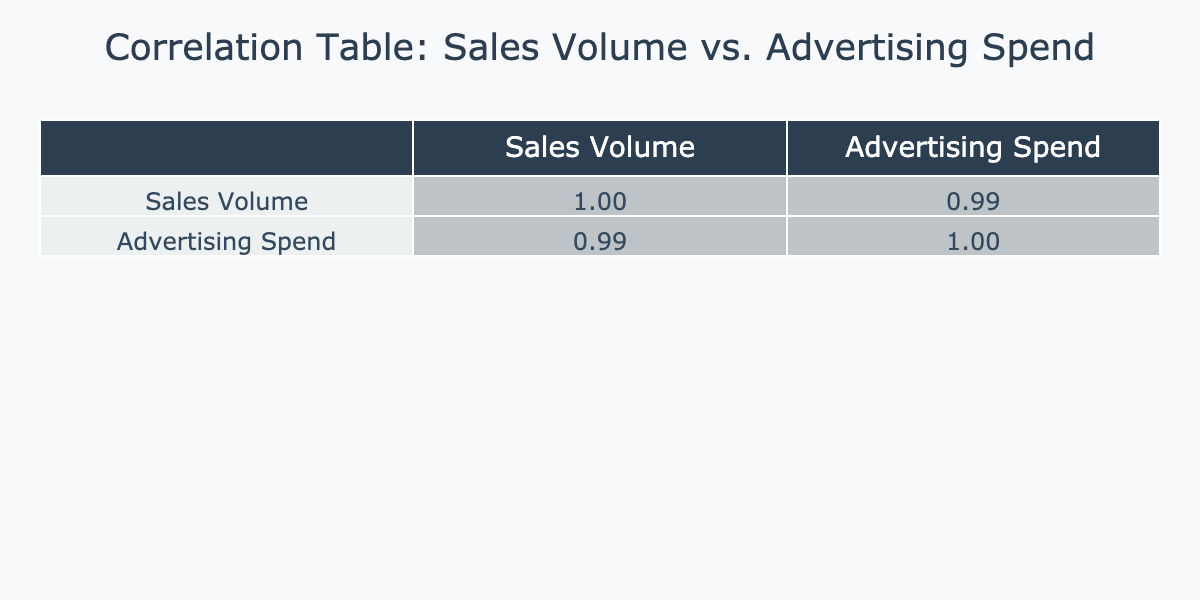What is the correlation coefficient between Sales Volume and Advertising Spend? The correlation coefficient between Sales Volume and Advertising Spend can be found in the correlation table, specifically in the cell corresponding to these two variables. It shows a positive value indicating a relationship.
Answer: Positive value Which region had the highest Sales Volume? Looking at the Sales Volume column, Asia has the highest Sales Volume at 15000 units.
Answer: Asia Is it true that Europe has a lower Advertising Spend than North America? By comparing the Advertising Spend values, Europe has 450000 USD, while North America has 500000 USD. Therefore, since Europe’s spend is less than North America's, the statement is true.
Answer: True What is the total Sales Volume across all regions? To find the total Sales Volume, we sum the Sales Volume values from all regions: 12000 (North America) + 9500 (Europe) + 15000 (Asia) + 7000 (South America) + 4000 (Africa) + 5000 (Australia) + 3000 (Middle East) = 51000 units.
Answer: 51000 units What is the average Advertising Spend among the regions? To find the average Advertising Spend, we sum all the Advertising Spend values: 500000 + 450000 + 600000 + 300000 + 200000 + 250000 + 150000 = 2150000 USD. Then we divide by the number of regions (7): 2150000 / 7 = 300000 USD.
Answer: 300000 USD Which region has the lowest Sales Volume? From the Sales Volume column, Africa has the lowest Sales Volume at 4000 units.
Answer: Africa Does South America have a higher Sales Volume than Australia? Comparing the Sales Volume values in the table, South America has 7000 units, while Australia has 5000 units. Since 7000 is greater than 5000, the statement is true.
Answer: True What is the difference in Advertising Spend between Asia and South America? To calculate the difference, we take the Advertising Spend of Asia (600000 USD) and subtract the Advertising Spend of South America (300000 USD): 600000 - 300000 = 300000 USD.
Answer: 300000 USD 